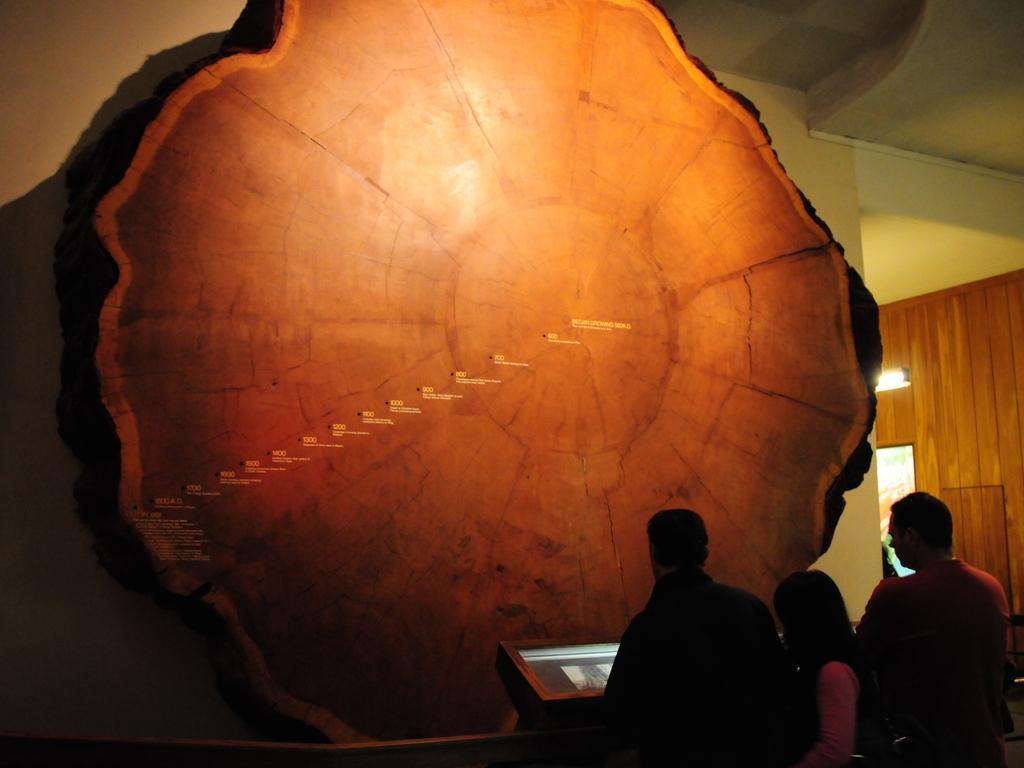Please provide a concise description of this image. In this image there is a big slice of wooden trunk attached to the wall. There is a display screen. Before it there are few persons standing on the floor. Right side there is a light , below it there is a door. 